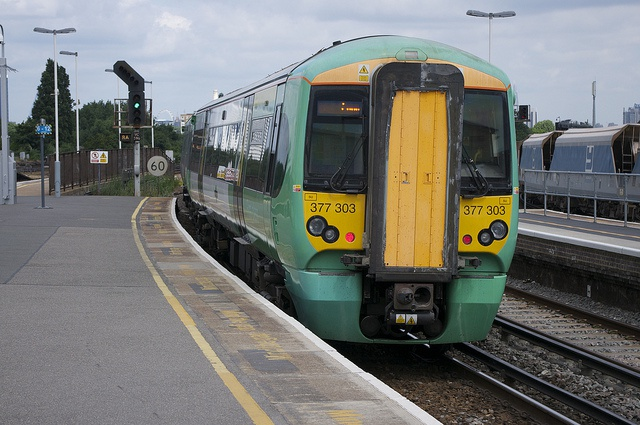Describe the objects in this image and their specific colors. I can see train in lightgray, black, gray, tan, and darkgray tones, train in lightgray, gray, black, darkgray, and darkblue tones, traffic light in lightgray, black, teal, and gray tones, and traffic light in lightgray, black, darkgray, lavender, and blue tones in this image. 